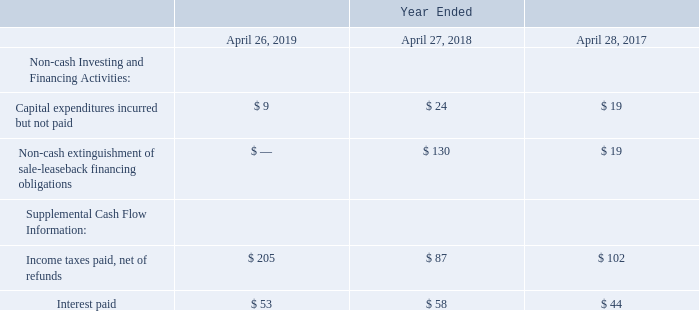Statements of cash flows additional information (in millions):
Non-cash investing and financing activities and supplemental cash flow information are as follows:
Which years does the table provide information for non-cash investing and financing activities and supplemental cash flow information for? 2019, 2018, 2017. What was the capital expenditures incurred but not paid in 2019?
Answer scale should be: million. 9. What was the non-cash extinguishment of sale-leaseback financing in 2017?
Answer scale should be: million. 19. How many years did interest paid exceed $50 million? 2019##2018
Answer: 2. What was the change in capital expenditures incurred but not paid between 2017 and 2018?
Answer scale should be: million. 24-19
Answer: 5. What was the percentage change in income taxes paid, net of refunds between 2018 and 2019?
Answer scale should be: percent. (205-87)/87
Answer: 135.63. 